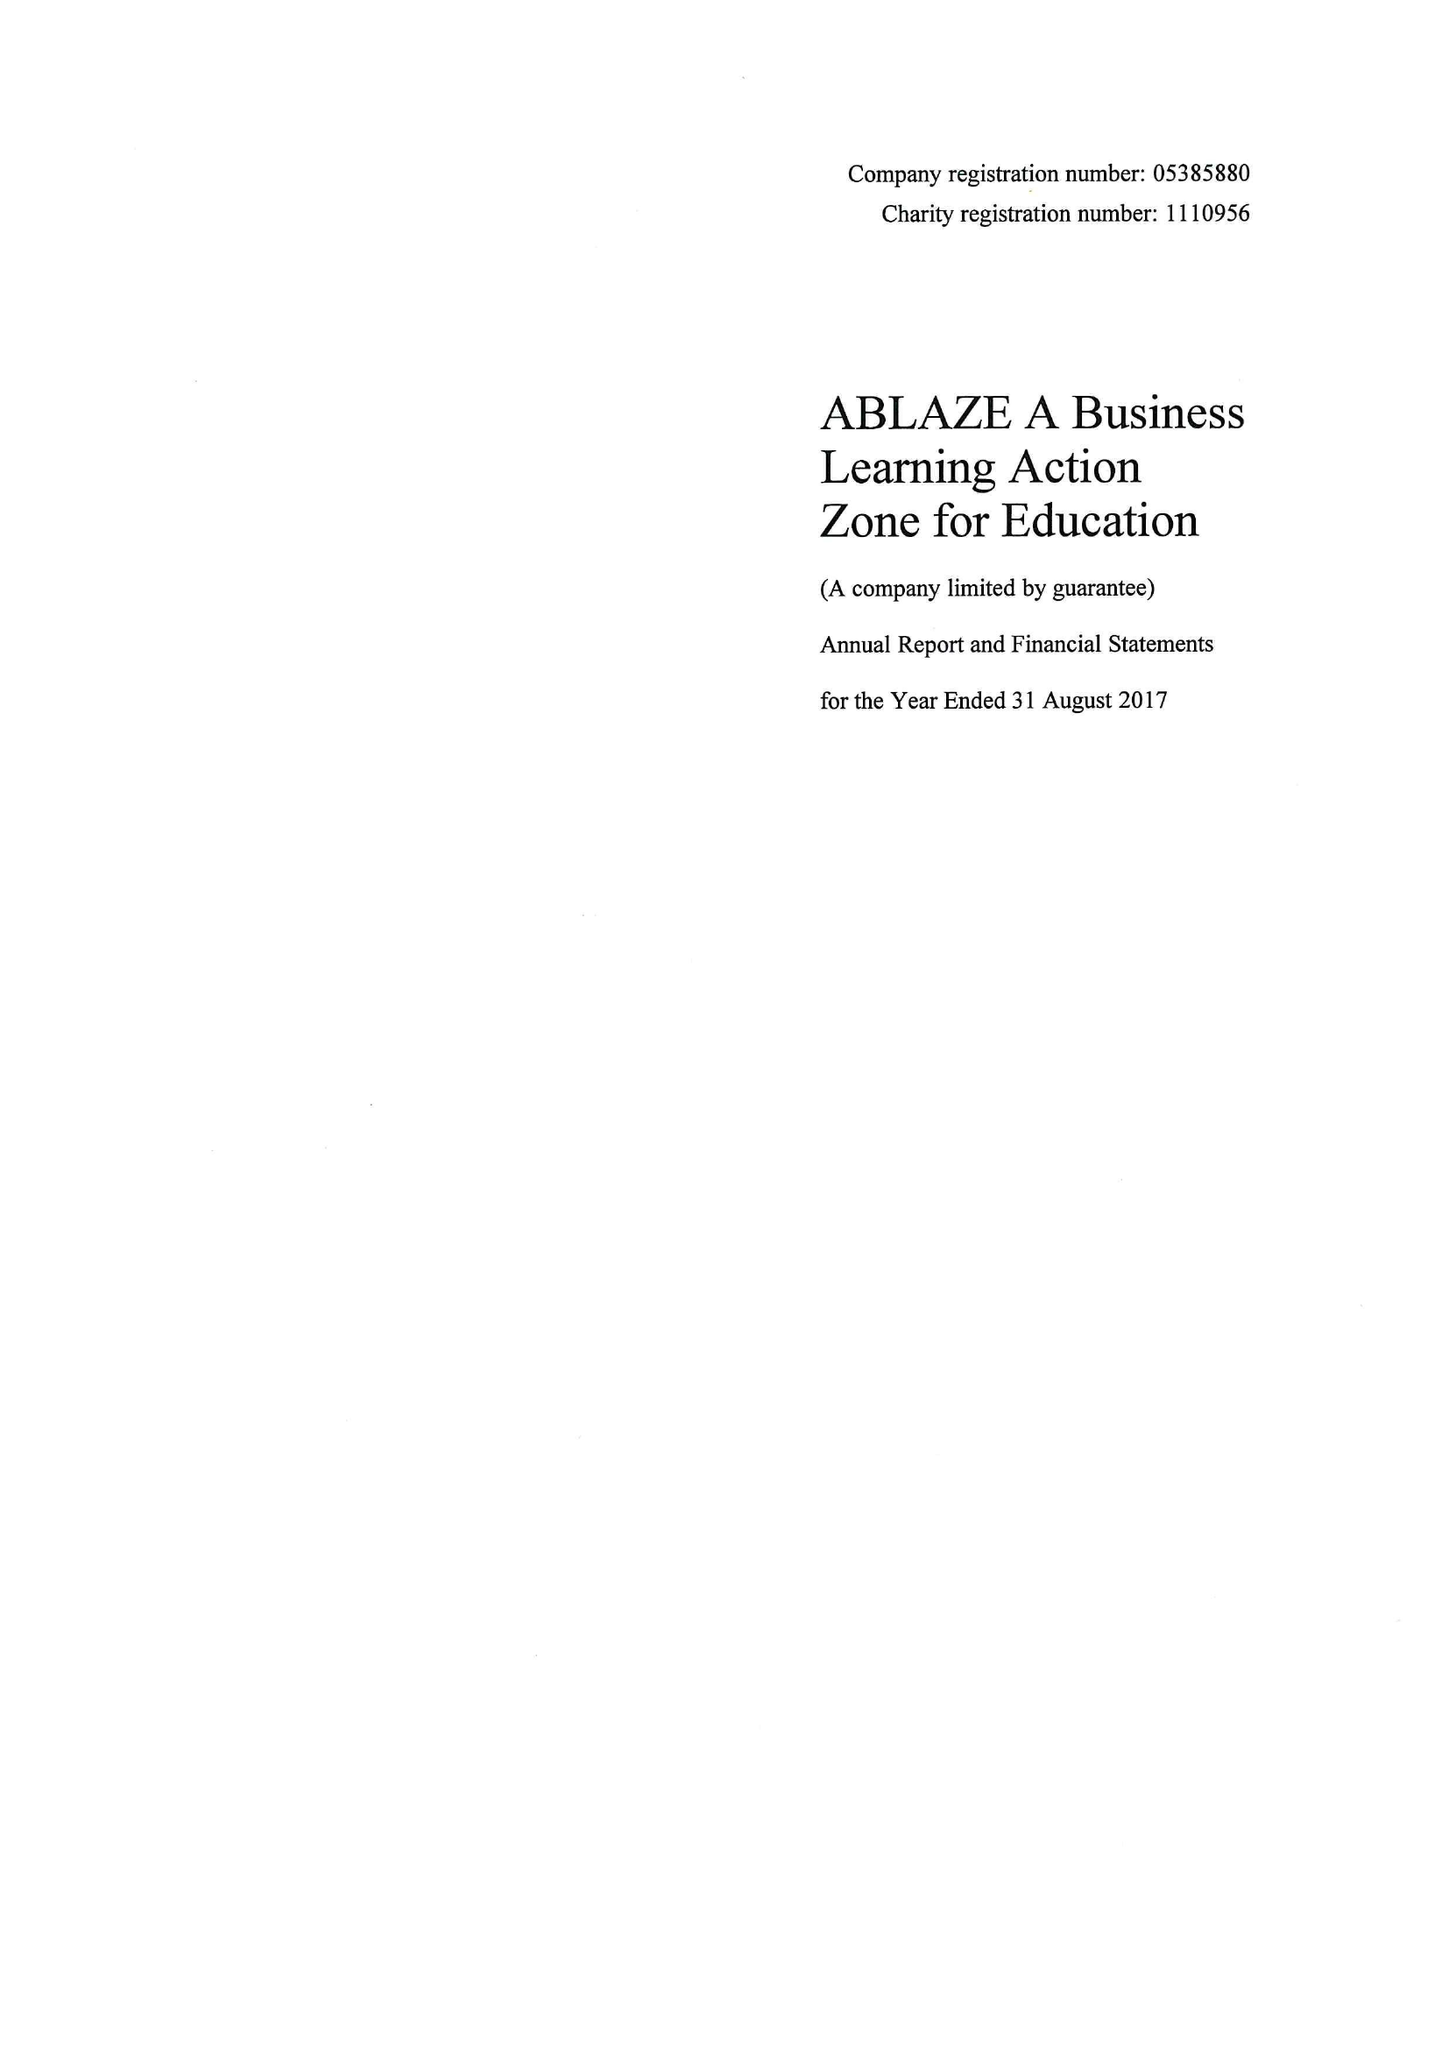What is the value for the charity_number?
Answer the question using a single word or phrase. 1110956 